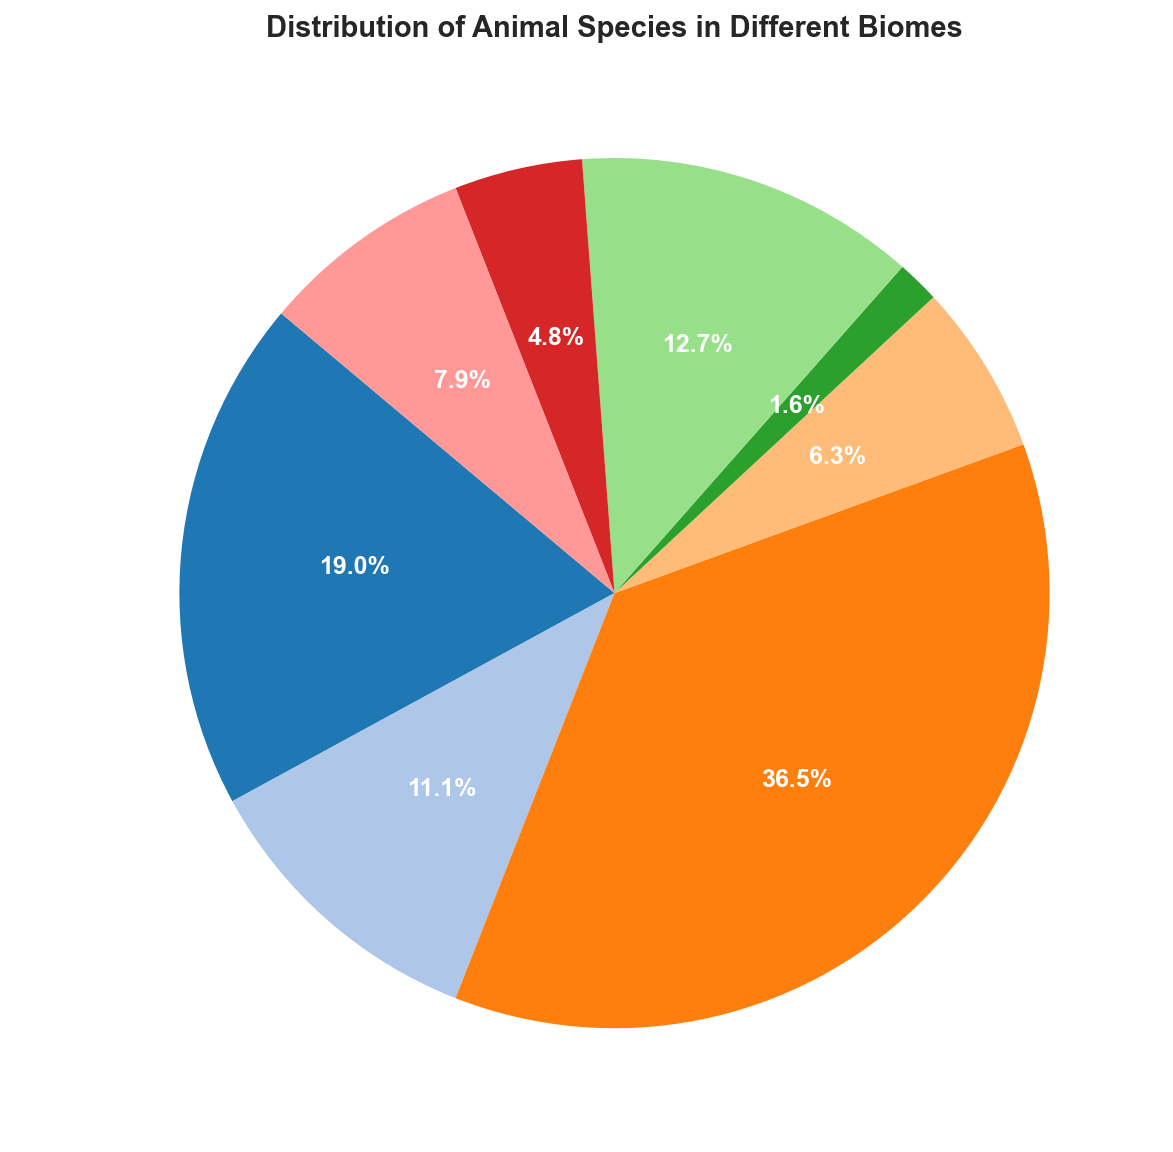What percentage of animal species are found in the Ocean biome? Locate the section labeled as "Ocean" in the pie chart. Note the percentage displayed within or near this section.
Answer: 37.1% Which biome has the second highest count of animal species? Identify the largest wedge first, which is the Ocean. Then locate the second largest wedge, labeled as "Rainforest."
Answer: Rainforest Compare the species count between the Desert and Grassland biomes. Which is greater and by how much? Locate the wedges labeled "Desert" and "Grassland." Note the species counts of 700,000 and 400,000, respectively. Subtract the Grassland count from the Desert count: 700,000 - 400,000.
Answer: Desert, by 300,000 How do the species counts of Tundra and Taiga combined compare to the Temperate Forest? Add the species counts for Tundra (100,000) and Taiga (300,000): 100,000 + 300,000 = 400,000. Compare this sum to the Temperate Forest count (800,000).
Answer: Temperate Forest is 400,000 more What is the ratio of species counts between the Ocean and the Wetlands biomes? Note the species counts for Ocean (2,300,000) and Wetlands (500,000). Divide the Ocean count by the Wetlands count: 2,300,000 / 500,000.
Answer: 4.6:1 